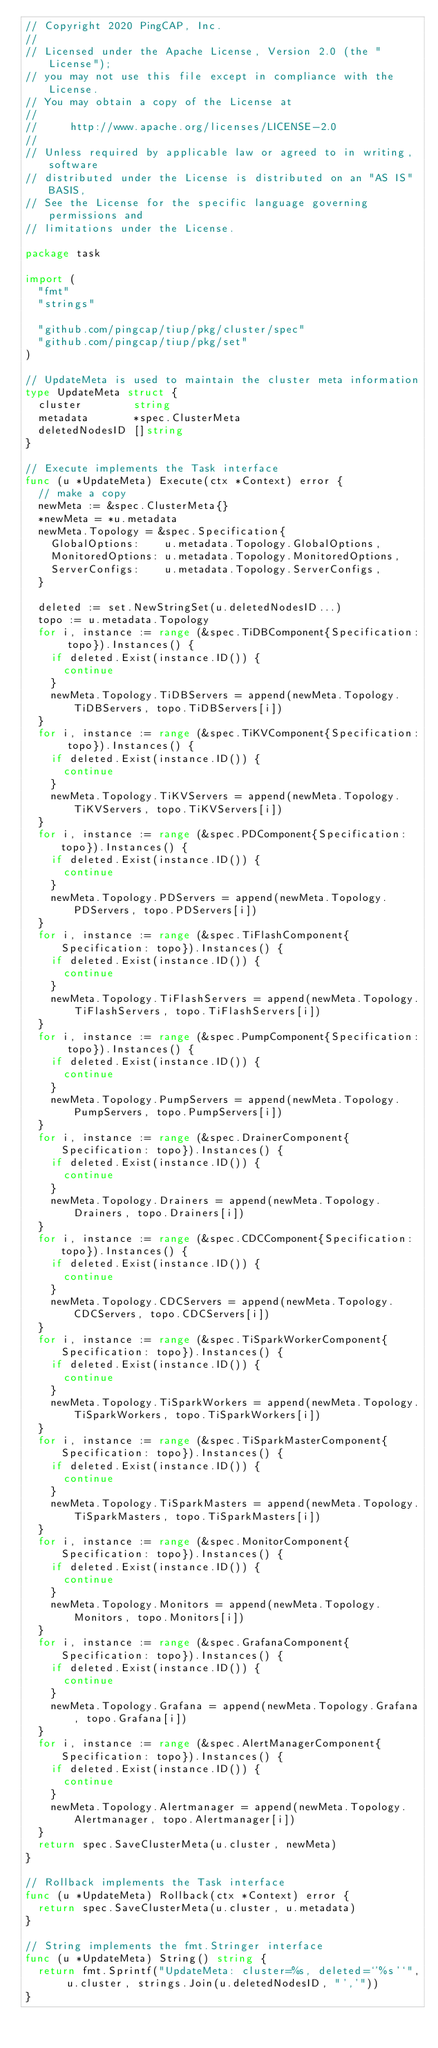<code> <loc_0><loc_0><loc_500><loc_500><_Go_>// Copyright 2020 PingCAP, Inc.
//
// Licensed under the Apache License, Version 2.0 (the "License");
// you may not use this file except in compliance with the License.
// You may obtain a copy of the License at
//
//     http://www.apache.org/licenses/LICENSE-2.0
//
// Unless required by applicable law or agreed to in writing, software
// distributed under the License is distributed on an "AS IS" BASIS,
// See the License for the specific language governing permissions and
// limitations under the License.

package task

import (
	"fmt"
	"strings"

	"github.com/pingcap/tiup/pkg/cluster/spec"
	"github.com/pingcap/tiup/pkg/set"
)

// UpdateMeta is used to maintain the cluster meta information
type UpdateMeta struct {
	cluster        string
	metadata       *spec.ClusterMeta
	deletedNodesID []string
}

// Execute implements the Task interface
func (u *UpdateMeta) Execute(ctx *Context) error {
	// make a copy
	newMeta := &spec.ClusterMeta{}
	*newMeta = *u.metadata
	newMeta.Topology = &spec.Specification{
		GlobalOptions:    u.metadata.Topology.GlobalOptions,
		MonitoredOptions: u.metadata.Topology.MonitoredOptions,
		ServerConfigs:    u.metadata.Topology.ServerConfigs,
	}

	deleted := set.NewStringSet(u.deletedNodesID...)
	topo := u.metadata.Topology
	for i, instance := range (&spec.TiDBComponent{Specification: topo}).Instances() {
		if deleted.Exist(instance.ID()) {
			continue
		}
		newMeta.Topology.TiDBServers = append(newMeta.Topology.TiDBServers, topo.TiDBServers[i])
	}
	for i, instance := range (&spec.TiKVComponent{Specification: topo}).Instances() {
		if deleted.Exist(instance.ID()) {
			continue
		}
		newMeta.Topology.TiKVServers = append(newMeta.Topology.TiKVServers, topo.TiKVServers[i])
	}
	for i, instance := range (&spec.PDComponent{Specification: topo}).Instances() {
		if deleted.Exist(instance.ID()) {
			continue
		}
		newMeta.Topology.PDServers = append(newMeta.Topology.PDServers, topo.PDServers[i])
	}
	for i, instance := range (&spec.TiFlashComponent{Specification: topo}).Instances() {
		if deleted.Exist(instance.ID()) {
			continue
		}
		newMeta.Topology.TiFlashServers = append(newMeta.Topology.TiFlashServers, topo.TiFlashServers[i])
	}
	for i, instance := range (&spec.PumpComponent{Specification: topo}).Instances() {
		if deleted.Exist(instance.ID()) {
			continue
		}
		newMeta.Topology.PumpServers = append(newMeta.Topology.PumpServers, topo.PumpServers[i])
	}
	for i, instance := range (&spec.DrainerComponent{Specification: topo}).Instances() {
		if deleted.Exist(instance.ID()) {
			continue
		}
		newMeta.Topology.Drainers = append(newMeta.Topology.Drainers, topo.Drainers[i])
	}
	for i, instance := range (&spec.CDCComponent{Specification: topo}).Instances() {
		if deleted.Exist(instance.ID()) {
			continue
		}
		newMeta.Topology.CDCServers = append(newMeta.Topology.CDCServers, topo.CDCServers[i])
	}
	for i, instance := range (&spec.TiSparkWorkerComponent{Specification: topo}).Instances() {
		if deleted.Exist(instance.ID()) {
			continue
		}
		newMeta.Topology.TiSparkWorkers = append(newMeta.Topology.TiSparkWorkers, topo.TiSparkWorkers[i])
	}
	for i, instance := range (&spec.TiSparkMasterComponent{Specification: topo}).Instances() {
		if deleted.Exist(instance.ID()) {
			continue
		}
		newMeta.Topology.TiSparkMasters = append(newMeta.Topology.TiSparkMasters, topo.TiSparkMasters[i])
	}
	for i, instance := range (&spec.MonitorComponent{Specification: topo}).Instances() {
		if deleted.Exist(instance.ID()) {
			continue
		}
		newMeta.Topology.Monitors = append(newMeta.Topology.Monitors, topo.Monitors[i])
	}
	for i, instance := range (&spec.GrafanaComponent{Specification: topo}).Instances() {
		if deleted.Exist(instance.ID()) {
			continue
		}
		newMeta.Topology.Grafana = append(newMeta.Topology.Grafana, topo.Grafana[i])
	}
	for i, instance := range (&spec.AlertManagerComponent{Specification: topo}).Instances() {
		if deleted.Exist(instance.ID()) {
			continue
		}
		newMeta.Topology.Alertmanager = append(newMeta.Topology.Alertmanager, topo.Alertmanager[i])
	}
	return spec.SaveClusterMeta(u.cluster, newMeta)
}

// Rollback implements the Task interface
func (u *UpdateMeta) Rollback(ctx *Context) error {
	return spec.SaveClusterMeta(u.cluster, u.metadata)
}

// String implements the fmt.Stringer interface
func (u *UpdateMeta) String() string {
	return fmt.Sprintf("UpdateMeta: cluster=%s, deleted=`'%s'`", u.cluster, strings.Join(u.deletedNodesID, "','"))
}
</code> 